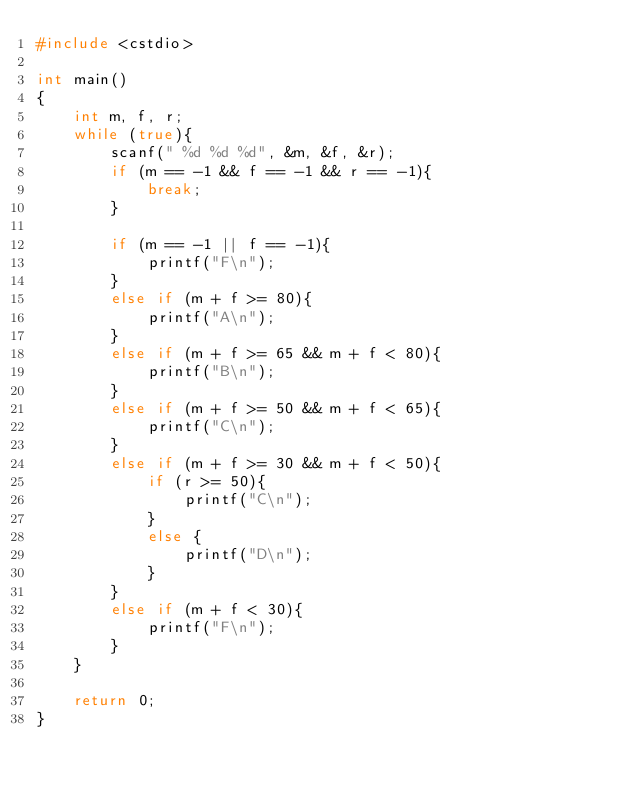<code> <loc_0><loc_0><loc_500><loc_500><_C++_>#include <cstdio>

int main()
{
    int m, f, r;
    while (true){
        scanf(" %d %d %d", &m, &f, &r);
        if (m == -1 && f == -1 && r == -1){
            break;
        }

        if (m == -1 || f == -1){
            printf("F\n");
        }
        else if (m + f >= 80){
            printf("A\n");
        }
        else if (m + f >= 65 && m + f < 80){
            printf("B\n");
        }
        else if (m + f >= 50 && m + f < 65){
            printf("C\n");
        }
        else if (m + f >= 30 && m + f < 50){
            if (r >= 50){
                printf("C\n");
            }
            else {
                printf("D\n");
            }
        }
        else if (m + f < 30){
            printf("F\n");
        }
    }

    return 0;
}
        </code> 